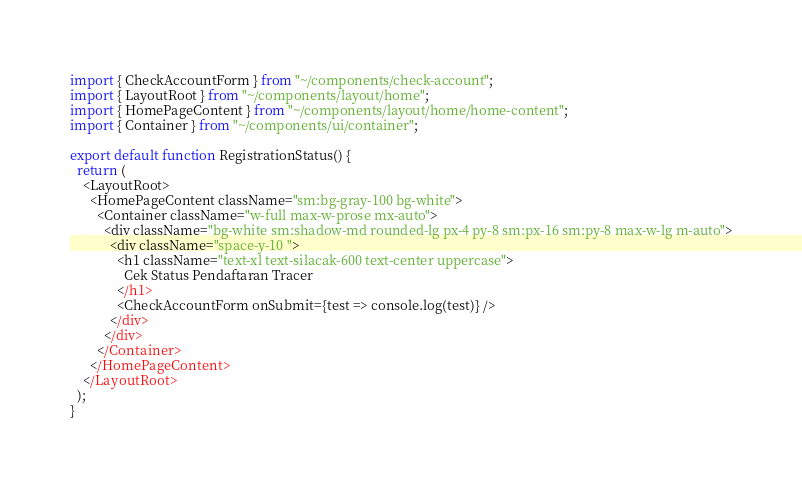<code> <loc_0><loc_0><loc_500><loc_500><_TypeScript_>import { CheckAccountForm } from "~/components/check-account";
import { LayoutRoot } from "~/components/layout/home";
import { HomePageContent } from "~/components/layout/home/home-content";
import { Container } from "~/components/ui/container";

export default function RegistrationStatus() {
  return (
    <LayoutRoot>
      <HomePageContent className="sm:bg-gray-100 bg-white">
        <Container className="w-full max-w-prose mx-auto">
          <div className="bg-white sm:shadow-md rounded-lg px-4 py-8 sm:px-16 sm:py-8 max-w-lg m-auto">
            <div className="space-y-10 ">
              <h1 className="text-xl text-silacak-600 text-center uppercase">
                Cek Status Pendaftaran Tracer
              </h1>
              <CheckAccountForm onSubmit={test => console.log(test)} />
            </div>
          </div>
        </Container>
      </HomePageContent>
    </LayoutRoot>
  );
}
</code> 